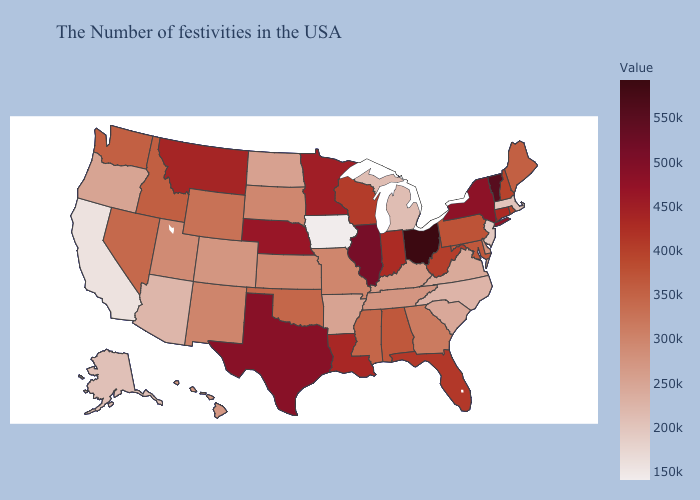Which states have the lowest value in the MidWest?
Answer briefly. Iowa. Among the states that border Arkansas , does Mississippi have the lowest value?
Short answer required. No. Does Delaware have the highest value in the USA?
Give a very brief answer. No. Does West Virginia have the lowest value in the USA?
Short answer required. No. 